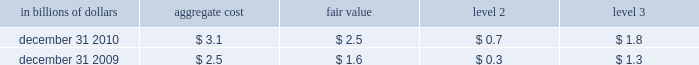The significant changes from december 31 , 2008 to december 31 , 2009 in level 3 assets and liabilities are due to : a net decrease in trading securities of $ 10.8 billion that was driven by : 2022 net transfers of $ 6.5 billion , due mainly to the transfer of debt 2013 securities from level 3 to level 2 due to increased liquidity and pricing transparency ; and net settlements of $ 5.8 billion , due primarily to the liquidations of 2013 subprime securities of $ 4.1 billion .
The change in net trading derivatives driven by : 2022 a net loss of $ 4.9 billion relating to complex derivative contracts , 2013 such as those linked to credit , equity and commodity exposures .
These losses include both realized and unrealized losses during 2009 and are partially offset by gains recognized in instruments that have been classified in levels 1 and 2 ; and net increase in derivative assets of $ 4.3 billion , which includes cash 2013 settlements of derivative contracts in an unrealized loss position , notably those linked to subprime exposures .
The decrease in level 3 investments of $ 6.9 billion primarily 2022 resulted from : a reduction of $ 5.0 billion , due mainly to paydowns on debt 2013 securities and sales of private equity investments ; the net transfer of investment securities from level 3 to level 2 2013 of $ 1.5 billion , due to increased availability of observable pricing inputs ; and net losses recognized of $ 0.4 billion due mainly to losses on non- 2013 marketable equity securities including write-downs on private equity investments .
The decrease in securities sold under agreements to repurchase of 2022 $ 9.1 billion is driven by a $ 8.6 billion net transfers from level 3 to level 2 as effective maturity dates on structured repos have shortened .
The decrease in long-term debt of $ 1.5 billion is driven mainly by 2022 $ 1.3 billion of net terminations of structured notes .
Transfers between level 1 and level 2 of the fair value hierarchy the company did not have any significant transfers of assets or liabilities between levels 1 and 2 of the fair value hierarchy during 2010 .
Items measured at fair value on a nonrecurring basis certain assets and liabilities are measured at fair value on a nonrecurring basis and therefore are not included in the tables above .
These include assets measured at cost that have been written down to fair value during the periods as a result of an impairment .
In addition , these assets include loans held-for-sale that are measured at locom that were recognized at fair value below cost at the end of the period .
The fair value of loans measured on a locom basis is determined where possible using quoted secondary-market prices .
Such loans are generally classified as level 2 of the fair value hierarchy given the level of activity in the market and the frequency of available quotes .
If no such quoted price exists , the fair value of a loan is determined using quoted prices for a similar asset or assets , adjusted for the specific attributes of that loan .
The table presents all loans held-for-sale that are carried at locom as of december 31 , 2010 and 2009 : in billions of dollars aggregate cost fair value level 2 level 3 .

What was the ratio of the net terminations of structured notes to the decrease in long-term debt? 
Computations: (1.3 / 1.5)
Answer: 0.86667. 